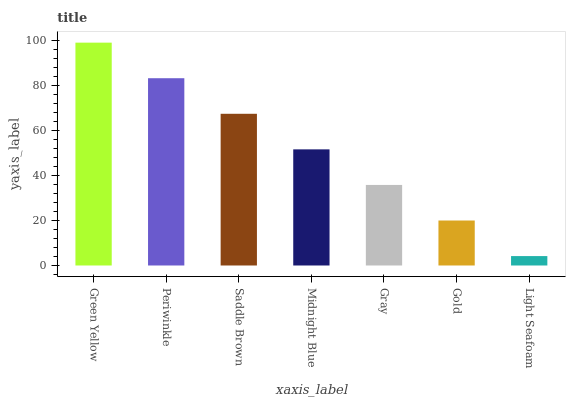Is Light Seafoam the minimum?
Answer yes or no. Yes. Is Green Yellow the maximum?
Answer yes or no. Yes. Is Periwinkle the minimum?
Answer yes or no. No. Is Periwinkle the maximum?
Answer yes or no. No. Is Green Yellow greater than Periwinkle?
Answer yes or no. Yes. Is Periwinkle less than Green Yellow?
Answer yes or no. Yes. Is Periwinkle greater than Green Yellow?
Answer yes or no. No. Is Green Yellow less than Periwinkle?
Answer yes or no. No. Is Midnight Blue the high median?
Answer yes or no. Yes. Is Midnight Blue the low median?
Answer yes or no. Yes. Is Light Seafoam the high median?
Answer yes or no. No. Is Green Yellow the low median?
Answer yes or no. No. 